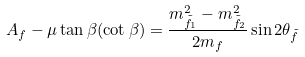<formula> <loc_0><loc_0><loc_500><loc_500>A _ { f } - \mu \tan \beta ( \cot \beta ) = \frac { m ^ { 2 } _ { \tilde { f } _ { 1 } } - m ^ { 2 } _ { \tilde { f } _ { 2 } } } { 2 m _ { f } } \sin 2 \theta _ { \tilde { f } }</formula> 